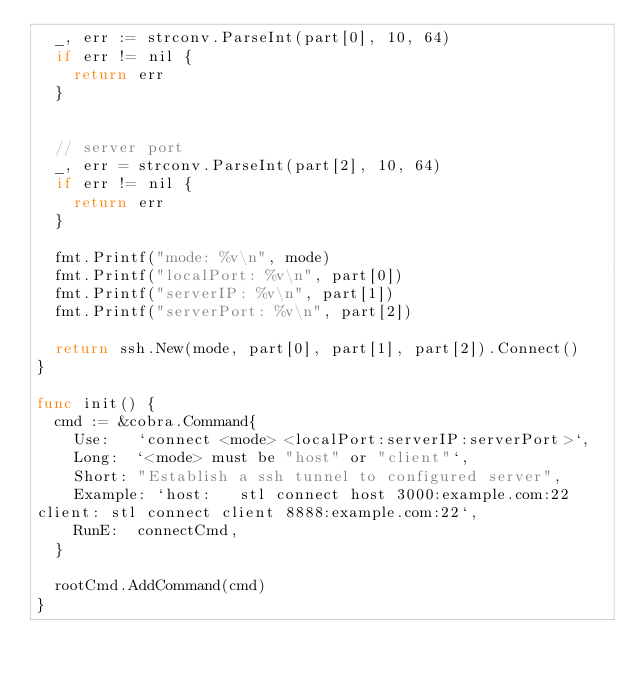<code> <loc_0><loc_0><loc_500><loc_500><_Go_>	_, err := strconv.ParseInt(part[0], 10, 64)
	if err != nil {
		return err
	}


	// server port
	_, err = strconv.ParseInt(part[2], 10, 64)
	if err != nil {
		return err
	}

	fmt.Printf("mode: %v\n", mode)
	fmt.Printf("localPort: %v\n", part[0])
	fmt.Printf("serverIP: %v\n", part[1])
	fmt.Printf("serverPort: %v\n", part[2])

	return ssh.New(mode, part[0], part[1], part[2]).Connect()
}

func init() {
	cmd := &cobra.Command{
		Use:   `connect <mode> <localPort:serverIP:serverPort>`,
		Long:  `<mode> must be "host" or "client"`,
		Short: "Establish a ssh tunnel to configured server",
		Example: `host:   stl connect host 3000:example.com:22
client: stl connect client 8888:example.com:22`,
		RunE:  connectCmd,
	}

	rootCmd.AddCommand(cmd)
}
</code> 